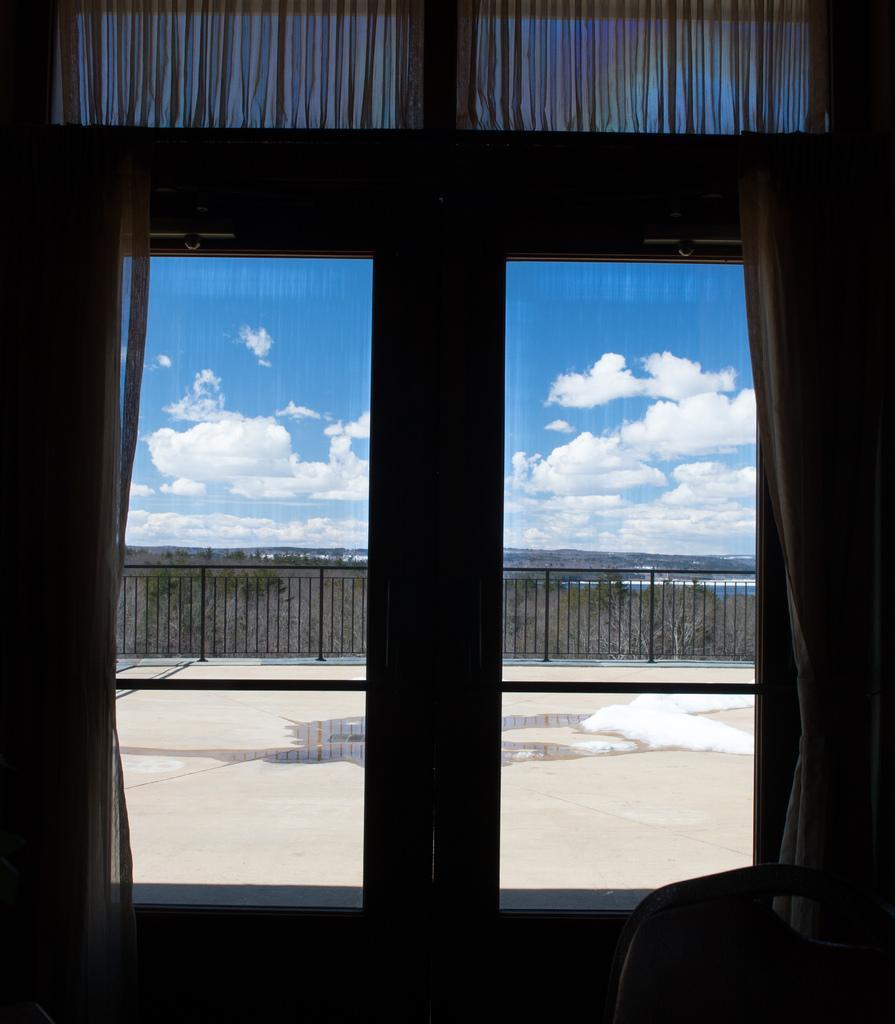Please provide a concise description of this image. In this image there is a glass window with curtains, on the other side of the glass window there is wooden fence, at the top of the image there are clouds in the sky. 